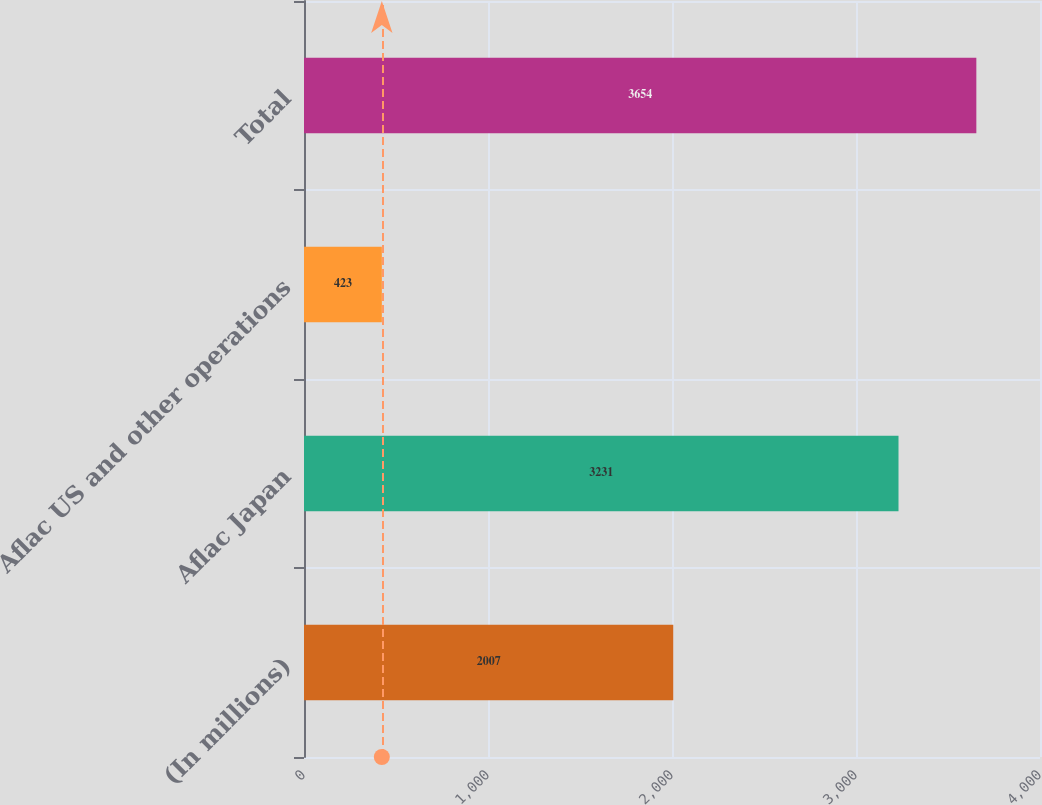Convert chart to OTSL. <chart><loc_0><loc_0><loc_500><loc_500><bar_chart><fcel>(In millions)<fcel>Aflac Japan<fcel>Aflac US and other operations<fcel>Total<nl><fcel>2007<fcel>3231<fcel>423<fcel>3654<nl></chart> 